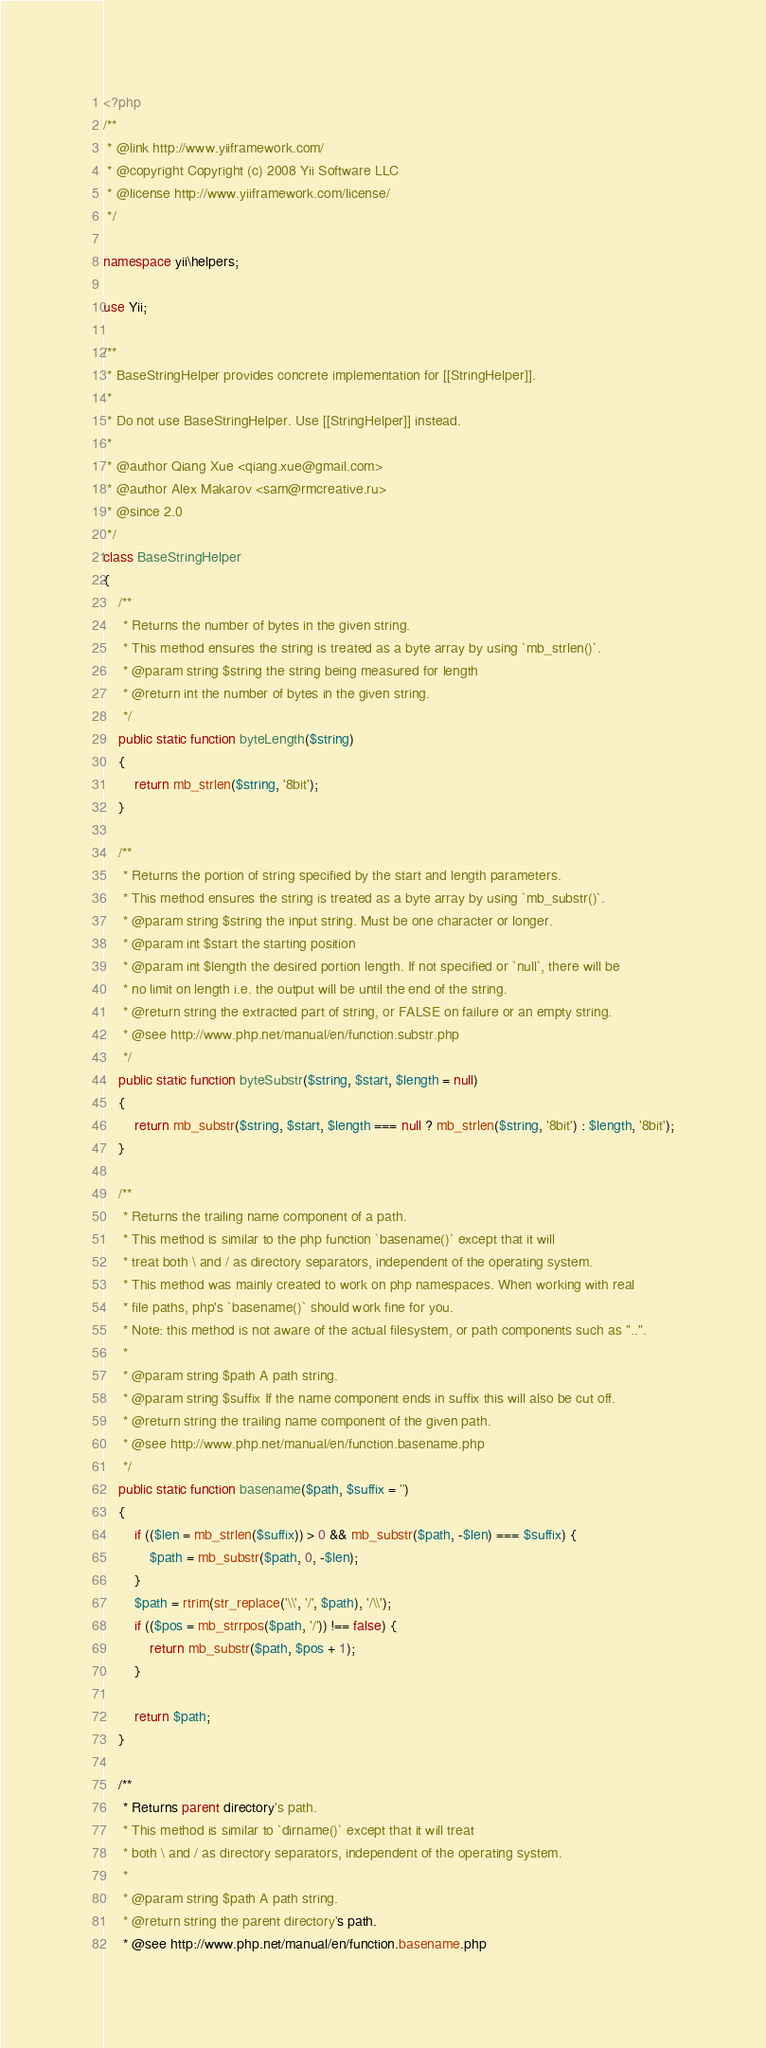<code> <loc_0><loc_0><loc_500><loc_500><_PHP_><?php
/**
 * @link http://www.yiiframework.com/
 * @copyright Copyright (c) 2008 Yii Software LLC
 * @license http://www.yiiframework.com/license/
 */

namespace yii\helpers;

use Yii;

/**
 * BaseStringHelper provides concrete implementation for [[StringHelper]].
 *
 * Do not use BaseStringHelper. Use [[StringHelper]] instead.
 *
 * @author Qiang Xue <qiang.xue@gmail.com>
 * @author Alex Makarov <sam@rmcreative.ru>
 * @since 2.0
 */
class BaseStringHelper
{
    /**
     * Returns the number of bytes in the given string.
     * This method ensures the string is treated as a byte array by using `mb_strlen()`.
     * @param string $string the string being measured for length
     * @return int the number of bytes in the given string.
     */
    public static function byteLength($string)
    {
        return mb_strlen($string, '8bit');
    }

    /**
     * Returns the portion of string specified by the start and length parameters.
     * This method ensures the string is treated as a byte array by using `mb_substr()`.
     * @param string $string the input string. Must be one character or longer.
     * @param int $start the starting position
     * @param int $length the desired portion length. If not specified or `null`, there will be
     * no limit on length i.e. the output will be until the end of the string.
     * @return string the extracted part of string, or FALSE on failure or an empty string.
     * @see http://www.php.net/manual/en/function.substr.php
     */
    public static function byteSubstr($string, $start, $length = null)
    {
        return mb_substr($string, $start, $length === null ? mb_strlen($string, '8bit') : $length, '8bit');
    }

    /**
     * Returns the trailing name component of a path.
     * This method is similar to the php function `basename()` except that it will
     * treat both \ and / as directory separators, independent of the operating system.
     * This method was mainly created to work on php namespaces. When working with real
     * file paths, php's `basename()` should work fine for you.
     * Note: this method is not aware of the actual filesystem, or path components such as "..".
     *
     * @param string $path A path string.
     * @param string $suffix If the name component ends in suffix this will also be cut off.
     * @return string the trailing name component of the given path.
     * @see http://www.php.net/manual/en/function.basename.php
     */
    public static function basename($path, $suffix = '')
    {
        if (($len = mb_strlen($suffix)) > 0 && mb_substr($path, -$len) === $suffix) {
            $path = mb_substr($path, 0, -$len);
        }
        $path = rtrim(str_replace('\\', '/', $path), '/\\');
        if (($pos = mb_strrpos($path, '/')) !== false) {
            return mb_substr($path, $pos + 1);
        }

        return $path;
    }

    /**
     * Returns parent directory's path.
     * This method is similar to `dirname()` except that it will treat
     * both \ and / as directory separators, independent of the operating system.
     *
     * @param string $path A path string.
     * @return string the parent directory's path.
     * @see http://www.php.net/manual/en/function.basename.php</code> 